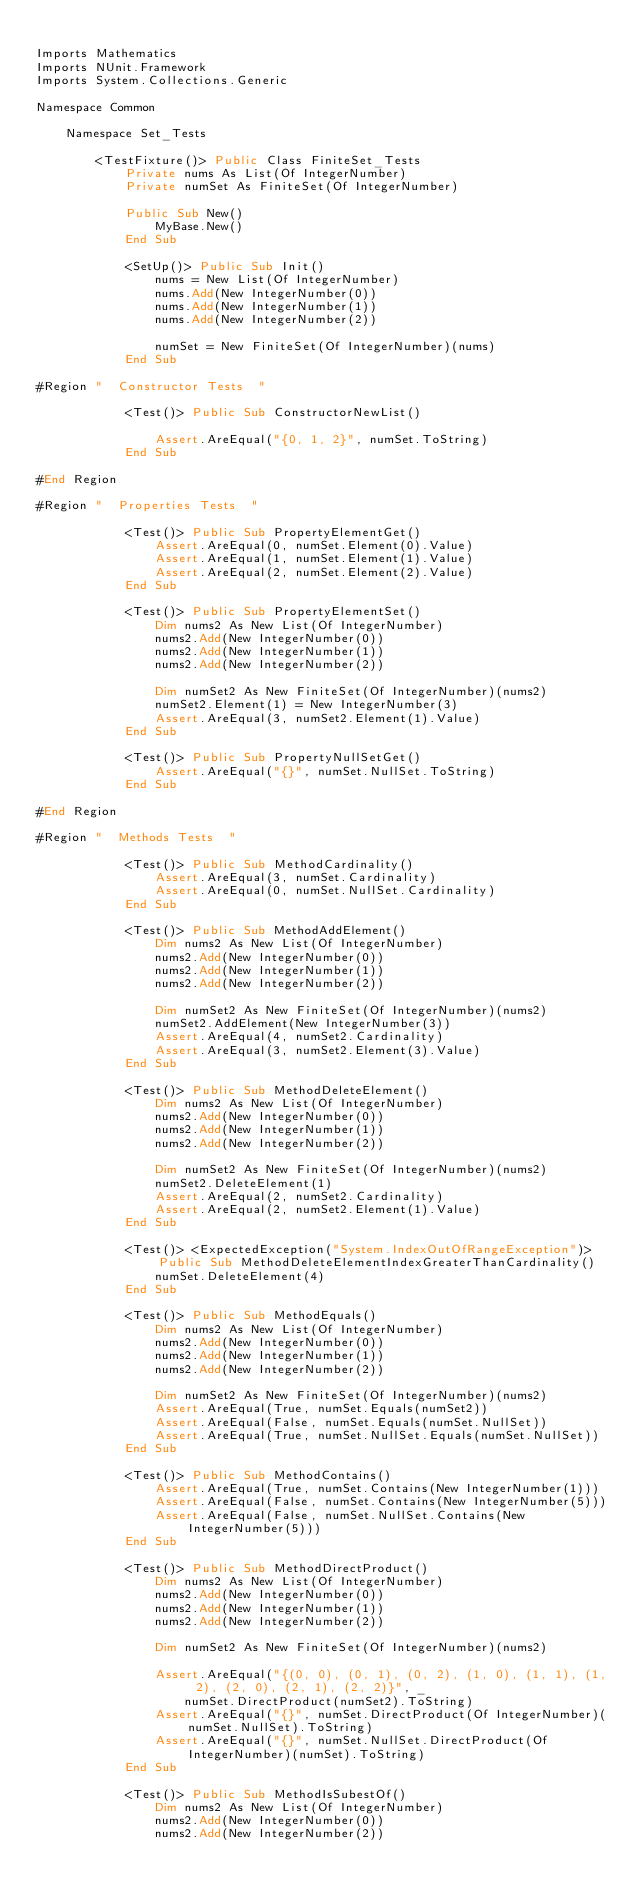Convert code to text. <code><loc_0><loc_0><loc_500><loc_500><_VisualBasic_>
Imports Mathematics
Imports NUnit.Framework
Imports System.Collections.Generic

Namespace Common

    Namespace Set_Tests

        <TestFixture()> Public Class FiniteSet_Tests
            Private nums As List(Of IntegerNumber)
            Private numSet As FiniteSet(Of IntegerNumber)

            Public Sub New()
                MyBase.New()
            End Sub

            <SetUp()> Public Sub Init()
                nums = New List(Of IntegerNumber)
                nums.Add(New IntegerNumber(0))
                nums.Add(New IntegerNumber(1))
                nums.Add(New IntegerNumber(2))

                numSet = New FiniteSet(Of IntegerNumber)(nums)
            End Sub

#Region "  Constructor Tests  "

            <Test()> Public Sub ConstructorNewList()

                Assert.AreEqual("{0, 1, 2}", numSet.ToString)
            End Sub

#End Region

#Region "  Properties Tests  "

            <Test()> Public Sub PropertyElementGet()
                Assert.AreEqual(0, numSet.Element(0).Value)
                Assert.AreEqual(1, numSet.Element(1).Value)
                Assert.AreEqual(2, numSet.Element(2).Value)
            End Sub

            <Test()> Public Sub PropertyElementSet()
                Dim nums2 As New List(Of IntegerNumber)
                nums2.Add(New IntegerNumber(0))
                nums2.Add(New IntegerNumber(1))
                nums2.Add(New IntegerNumber(2))

                Dim numSet2 As New FiniteSet(Of IntegerNumber)(nums2)
                numSet2.Element(1) = New IntegerNumber(3)
                Assert.AreEqual(3, numSet2.Element(1).Value)
            End Sub

            <Test()> Public Sub PropertyNullSetGet()
                Assert.AreEqual("{}", numSet.NullSet.ToString)
            End Sub

#End Region

#Region "  Methods Tests  "

            <Test()> Public Sub MethodCardinality()
                Assert.AreEqual(3, numSet.Cardinality)
                Assert.AreEqual(0, numSet.NullSet.Cardinality)
            End Sub

            <Test()> Public Sub MethodAddElement()
                Dim nums2 As New List(Of IntegerNumber)
                nums2.Add(New IntegerNumber(0))
                nums2.Add(New IntegerNumber(1))
                nums2.Add(New IntegerNumber(2))

                Dim numSet2 As New FiniteSet(Of IntegerNumber)(nums2)
                numSet2.AddElement(New IntegerNumber(3))
                Assert.AreEqual(4, numSet2.Cardinality)
                Assert.AreEqual(3, numSet2.Element(3).Value)
            End Sub

            <Test()> Public Sub MethodDeleteElement()
                Dim nums2 As New List(Of IntegerNumber)
                nums2.Add(New IntegerNumber(0))
                nums2.Add(New IntegerNumber(1))
                nums2.Add(New IntegerNumber(2))

                Dim numSet2 As New FiniteSet(Of IntegerNumber)(nums2)
                numSet2.DeleteElement(1)
                Assert.AreEqual(2, numSet2.Cardinality)
                Assert.AreEqual(2, numSet2.Element(1).Value)
            End Sub

            <Test()> <ExpectedException("System.IndexOutOfRangeException")> Public Sub MethodDeleteElementIndexGreaterThanCardinality()
                numSet.DeleteElement(4)
            End Sub

            <Test()> Public Sub MethodEquals()
                Dim nums2 As New List(Of IntegerNumber)
                nums2.Add(New IntegerNumber(0))
                nums2.Add(New IntegerNumber(1))
                nums2.Add(New IntegerNumber(2))

                Dim numSet2 As New FiniteSet(Of IntegerNumber)(nums2)
                Assert.AreEqual(True, numSet.Equals(numSet2))
                Assert.AreEqual(False, numSet.Equals(numSet.NullSet))
                Assert.AreEqual(True, numSet.NullSet.Equals(numSet.NullSet))
            End Sub

            <Test()> Public Sub MethodContains()
                Assert.AreEqual(True, numSet.Contains(New IntegerNumber(1)))
                Assert.AreEqual(False, numSet.Contains(New IntegerNumber(5)))
                Assert.AreEqual(False, numSet.NullSet.Contains(New IntegerNumber(5)))
            End Sub

            <Test()> Public Sub MethodDirectProduct()
                Dim nums2 As New List(Of IntegerNumber)
                nums2.Add(New IntegerNumber(0))
                nums2.Add(New IntegerNumber(1))
                nums2.Add(New IntegerNumber(2))

                Dim numSet2 As New FiniteSet(Of IntegerNumber)(nums2)

                Assert.AreEqual("{(0, 0), (0, 1), (0, 2), (1, 0), (1, 1), (1, 2), (2, 0), (2, 1), (2, 2)}", _
                    numSet.DirectProduct(numSet2).ToString)
                Assert.AreEqual("{}", numSet.DirectProduct(Of IntegerNumber)(numSet.NullSet).ToString)
                Assert.AreEqual("{}", numSet.NullSet.DirectProduct(Of IntegerNumber)(numSet).ToString)
            End Sub

            <Test()> Public Sub MethodIsSubestOf()
                Dim nums2 As New List(Of IntegerNumber)
                nums2.Add(New IntegerNumber(0))
                nums2.Add(New IntegerNumber(2))
</code> 